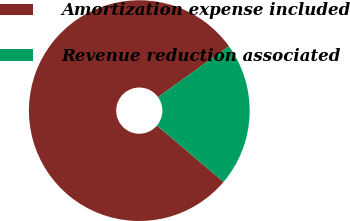Convert chart. <chart><loc_0><loc_0><loc_500><loc_500><pie_chart><fcel>Amortization expense included<fcel>Revenue reduction associated<nl><fcel>78.89%<fcel>21.11%<nl></chart> 